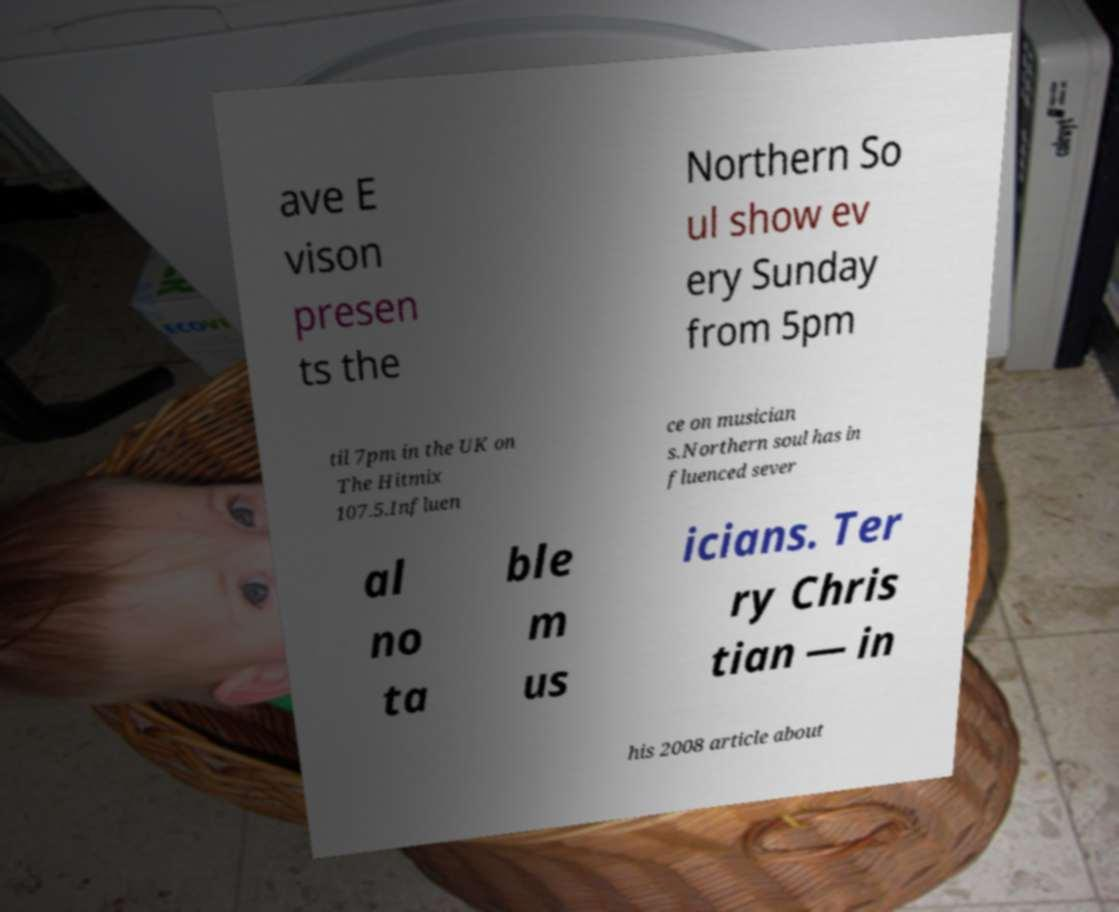Could you extract and type out the text from this image? ave E vison presen ts the Northern So ul show ev ery Sunday from 5pm til 7pm in the UK on The Hitmix 107.5.Influen ce on musician s.Northern soul has in fluenced sever al no ta ble m us icians. Ter ry Chris tian — in his 2008 article about 